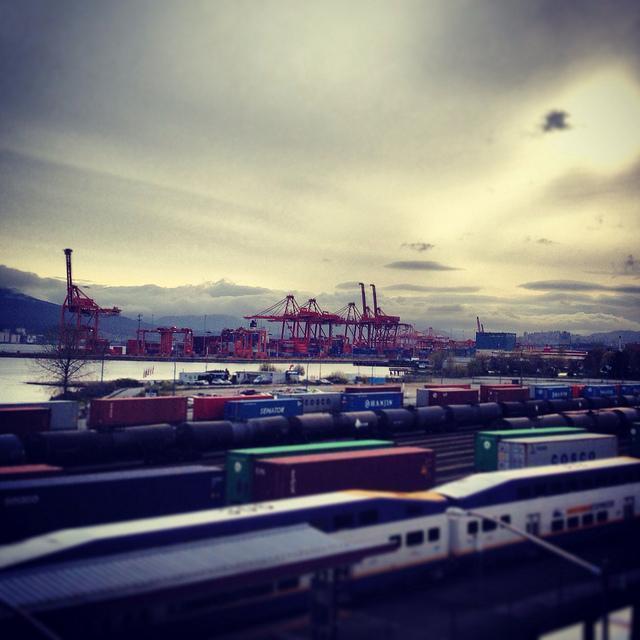How many trains are in the photo?
Give a very brief answer. 6. 